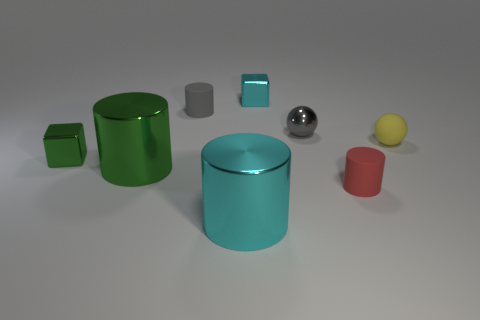Does the shiny cube that is behind the tiny yellow matte object have the same color as the tiny matte cylinder in front of the tiny yellow sphere?
Provide a succinct answer. No. What number of objects are either red cylinders or cyan shiny cylinders?
Offer a terse response. 2. What number of cyan things have the same material as the gray ball?
Offer a terse response. 2. Are there fewer small gray balls than small red metallic blocks?
Offer a very short reply. No. Does the sphere that is right of the gray ball have the same material as the big green cylinder?
Offer a very short reply. No. What number of cylinders are cyan metal things or gray matte objects?
Make the answer very short. 2. There is a rubber thing that is both behind the small green object and on the left side of the yellow thing; what is its shape?
Your answer should be compact. Cylinder. The big object that is behind the cylinder right of the tiny metal block behind the small gray sphere is what color?
Your response must be concise. Green. Are there fewer yellow rubber balls behind the small yellow rubber ball than cyan metallic blocks?
Keep it short and to the point. Yes. There is a rubber object left of the small cyan cube; is its shape the same as the shiny thing in front of the large green thing?
Offer a very short reply. Yes. 